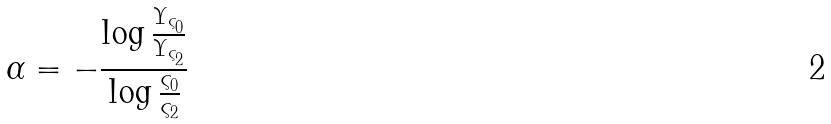Convert formula to latex. <formula><loc_0><loc_0><loc_500><loc_500>\alpha = - \frac { \log \frac { \Upsilon _ { \varsigma _ { 0 } } } { \Upsilon _ { \varsigma _ { 2 } } } } { \log \frac { \varsigma _ { 0 } } { \varsigma _ { 2 } } }</formula> 